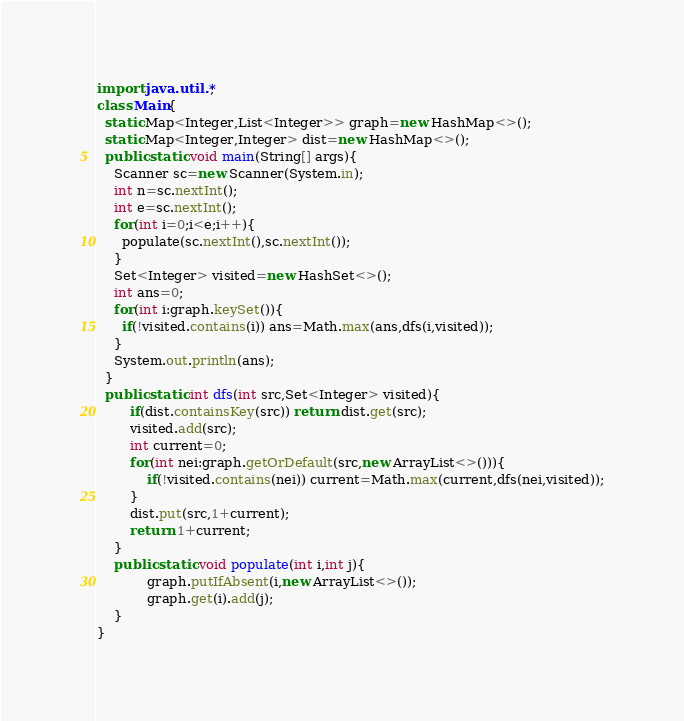Convert code to text. <code><loc_0><loc_0><loc_500><loc_500><_Java_>import java.util.*;
class Main{
  static Map<Integer,List<Integer>> graph=new HashMap<>();
  static Map<Integer,Integer> dist=new HashMap<>();
  public static void main(String[] args){
    Scanner sc=new Scanner(System.in);
    int n=sc.nextInt();
    int e=sc.nextInt();
    for(int i=0;i<e;i++){
      populate(sc.nextInt(),sc.nextInt());
    }
    Set<Integer> visited=new HashSet<>();
    int ans=0;
    for(int i:graph.keySet()){
      if(!visited.contains(i)) ans=Math.max(ans,dfs(i,visited));
    }
    System.out.println(ans);
  }
  public static int dfs(int src,Set<Integer> visited){
        if(dist.containsKey(src)) return dist.get(src);
        visited.add(src);
        int current=0;
        for(int nei:graph.getOrDefault(src,new ArrayList<>())){
            if(!visited.contains(nei)) current=Math.max(current,dfs(nei,visited));
        }
    	dist.put(src,1+current);
        return 1+current;
    }
    public static void populate(int i,int j){
            graph.putIfAbsent(i,new ArrayList<>());
            graph.get(i).add(j); 
    }
}</code> 